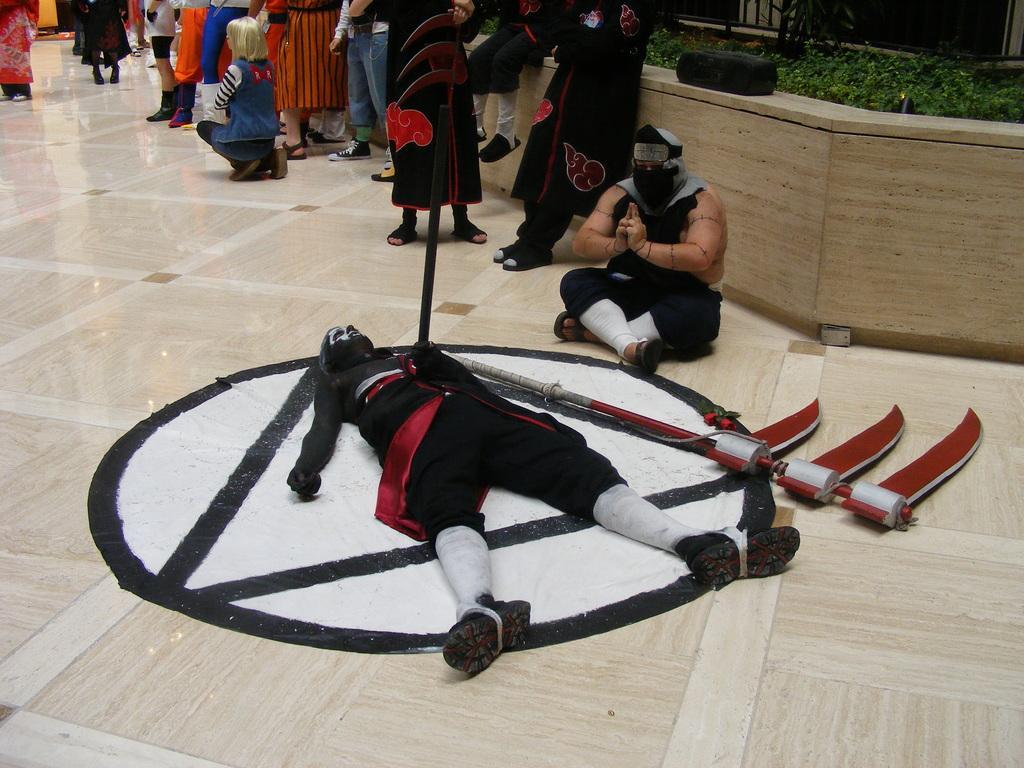Could you give a brief overview of what you see in this image? In this picture we can see a person lying and a few things are visible on the floor. We can see a few people, plants and other objects. There is a person sitting on the floor. We can see the reflections of some people, lights and other objects on the floor. 